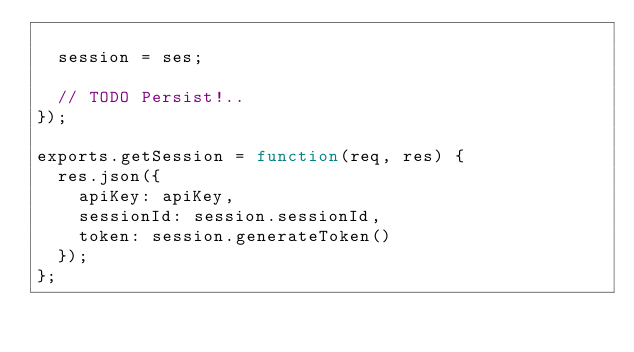Convert code to text. <code><loc_0><loc_0><loc_500><loc_500><_JavaScript_>
  session = ses;

  // TODO Persist!..
});

exports.getSession = function(req, res) {
  res.json({
    apiKey: apiKey,
    sessionId: session.sessionId,
    token: session.generateToken()
  });
};
</code> 